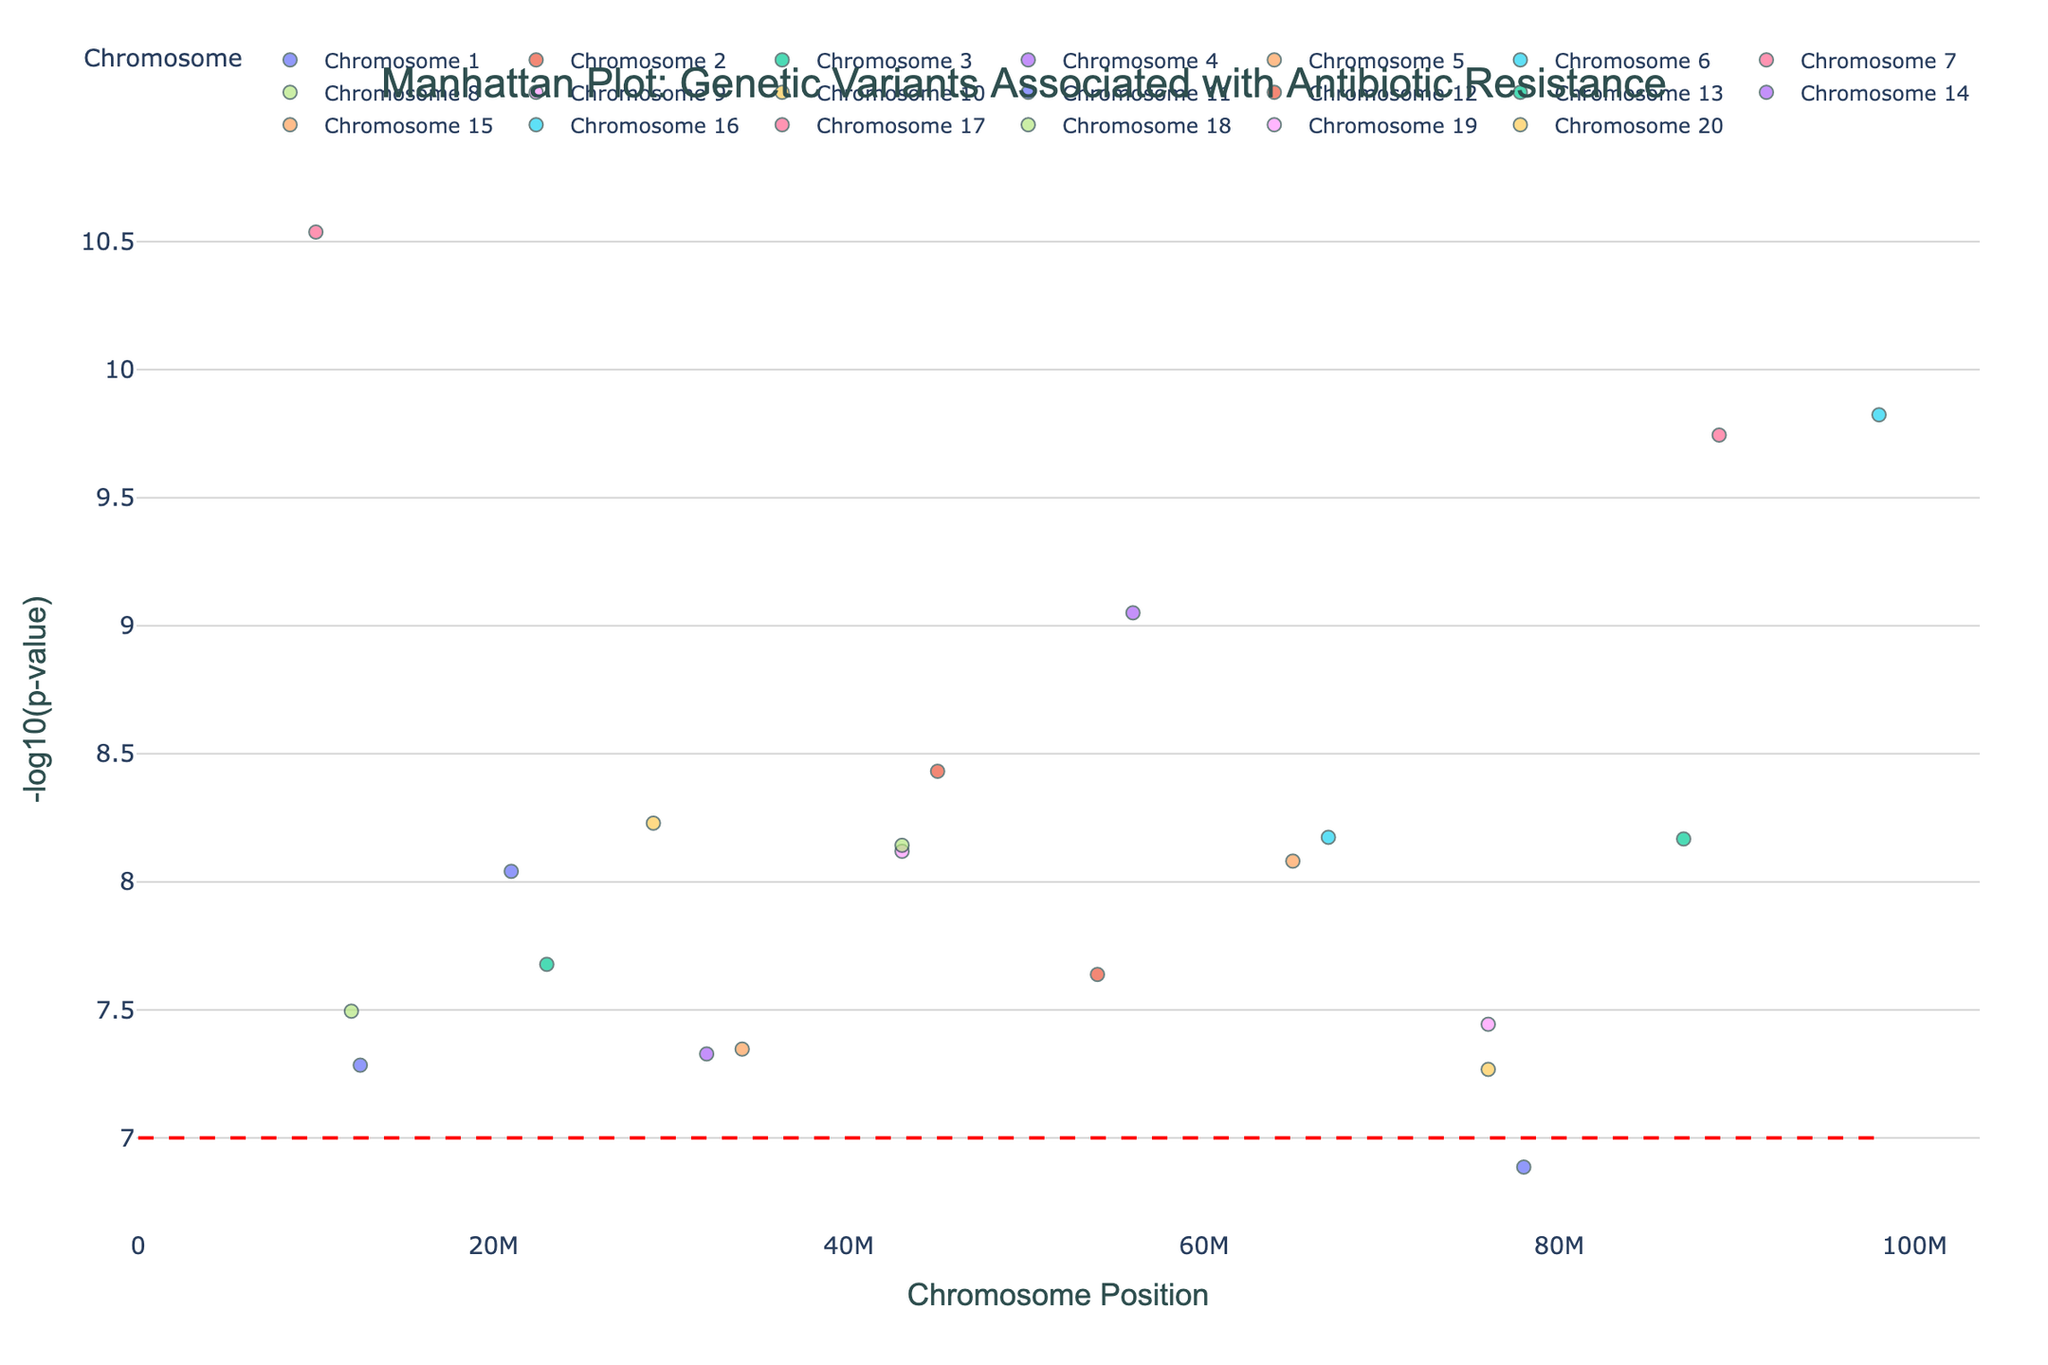What is the title of the figure? The title of the figure is written at the top and usually summarizes the data visualization in one sentence. In this plot, it explains the main focus of the study.
Answer: Manhattan Plot: Genetic Variants Associated with Antibiotic Resistance How many chromosomes are displayed in the plot? By observing the scatter plots with different colors and the legend, we can count the number of distinct chromosomes represented.
Answer: 20 Which gene has the highest significance value, and on which chromosome is it located? This requires identifying the data point with the maximum -log10(p-value) along the y-axis and noting the gene and chromosome associated with it. From the plot, this is found at the highest point.
Answer: ndm-1, Chromosome 17 What is the significance threshold line's -log10(p-value)? The significance threshold line is represented as a horizontal dashed red line across the plot. The y-axis will have a label at the crossing point, indicating the -log10(p-value).
Answer: 7 Which chromosome has the gene associated with Methicillin resistance, and what is its -log10(p-value)? We need to look through the hover text or legend for Methicillin and note the chromosome and the corresponding y-value.
Answer: Chromosome 4, -log10(p-value) ≈ 9.05 Between genes blaKPC and blaOXA-48, which one shows a higher significance level for Carbapenem resistance? This requires identifying the y-values for both genes and comparing them. By looking at their positions on the y-axis, we find which one is higher.
Answer: blaOXA-48 On which chromosome is the variance associated with Tetracycline resistance, and what is its position? We need to locate the gene tetM in the hover text or legend, then note the chromosome and position value.
Answer: Chromosome 9, Position 43000000 Calculate the average -log10(p-value) for the genes on chromosomes 1, 2, and 3. We need to find the -log10(p-value) for the genes on each of these chromosomes, sum them up and divide by the number of data points. (Chromosome 1: 7.28, 6.89; Chromosome 2: 8.43; Chromosome 3: 7.68) Average = (7.28 + 6.89 + 8.43 + 7.68) / 4
Answer: 7.57 Which antibiotics have their associated genes below the significance threshold line? This involves looking for data points that fall below the dashed red line for significance and identifying the corresponding antibiotics through hover text.
Answer: None 